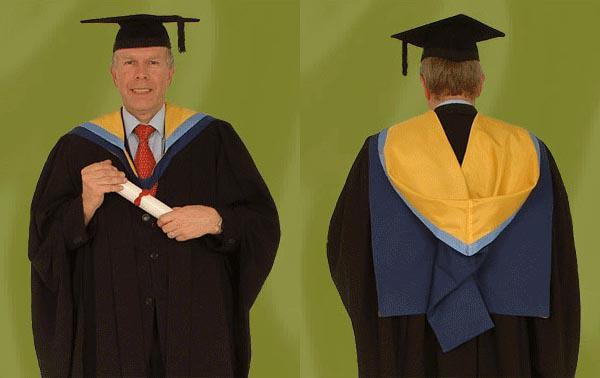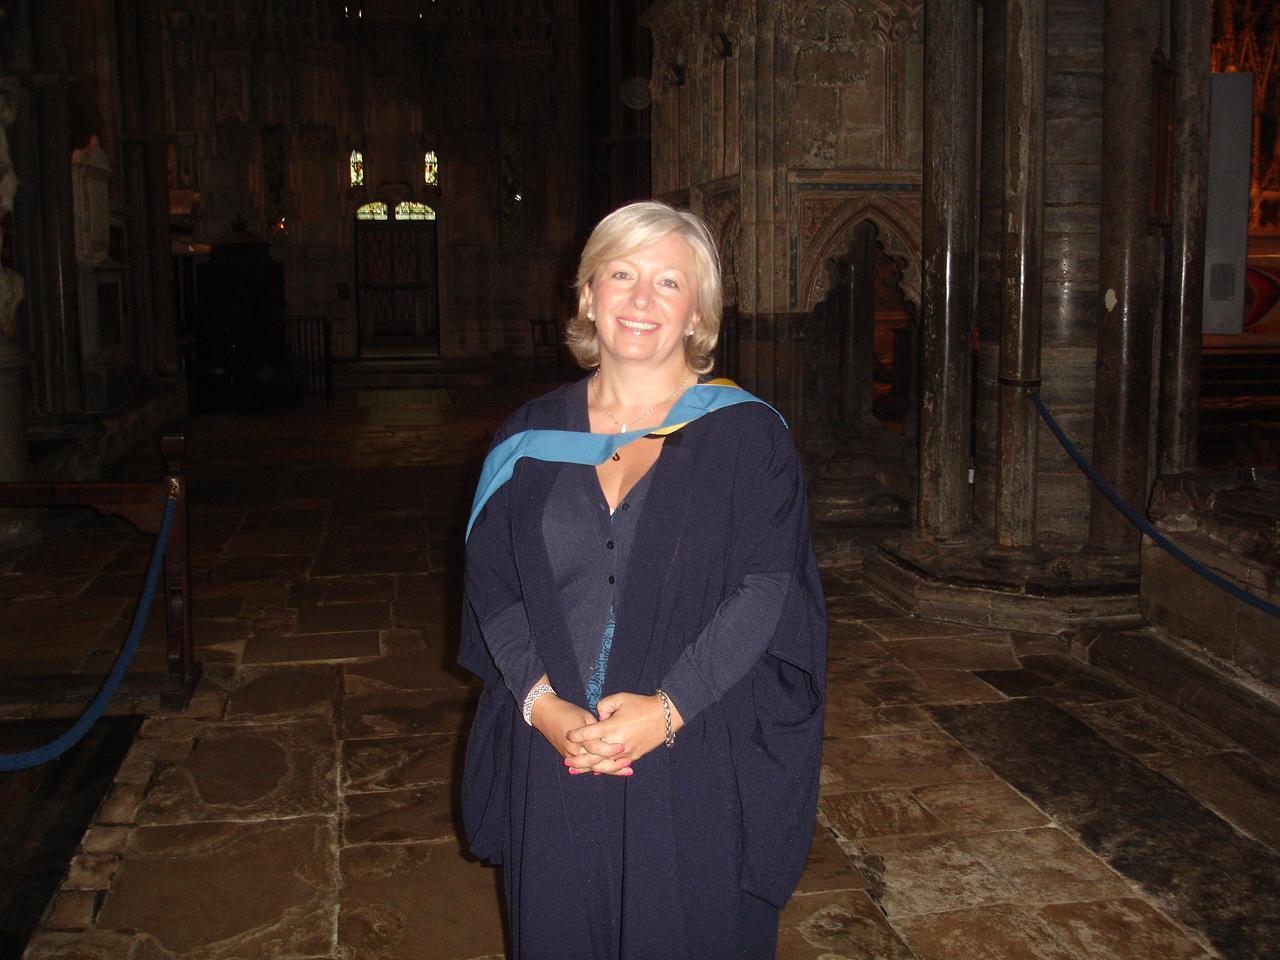The first image is the image on the left, the second image is the image on the right. Considering the images on both sides, is "A smiling woman with short hair is seen from the front wearing a sky blue gown, open to show her clothing, with dark navy blue and yellow at her neck." valid? Answer yes or no. No. The first image is the image on the left, the second image is the image on the right. Evaluate the accuracy of this statement regarding the images: "One of the images shows a man wearing a blue and yellow stole holding a rolled up diploma in his hands that is tied with a red ribbon.". Is it true? Answer yes or no. Yes. 